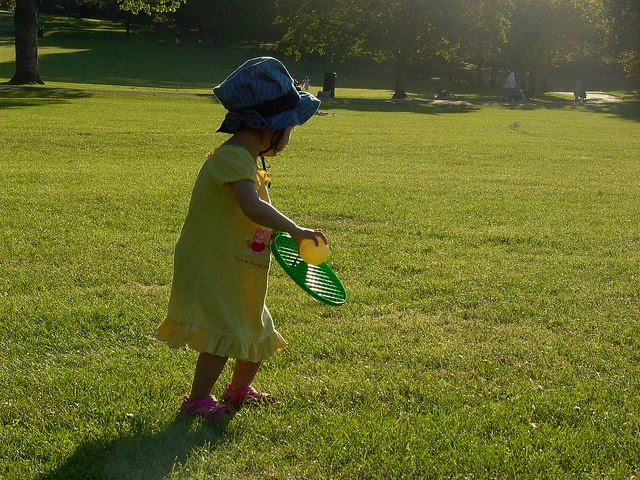Describe the objects in this image and their specific colors. I can see people in black, darkgreen, and maroon tones, tennis racket in black, darkgreen, and ivory tones, sports ball in black and olive tones, people in black and gray tones, and people in black, gray, and darkgray tones in this image. 